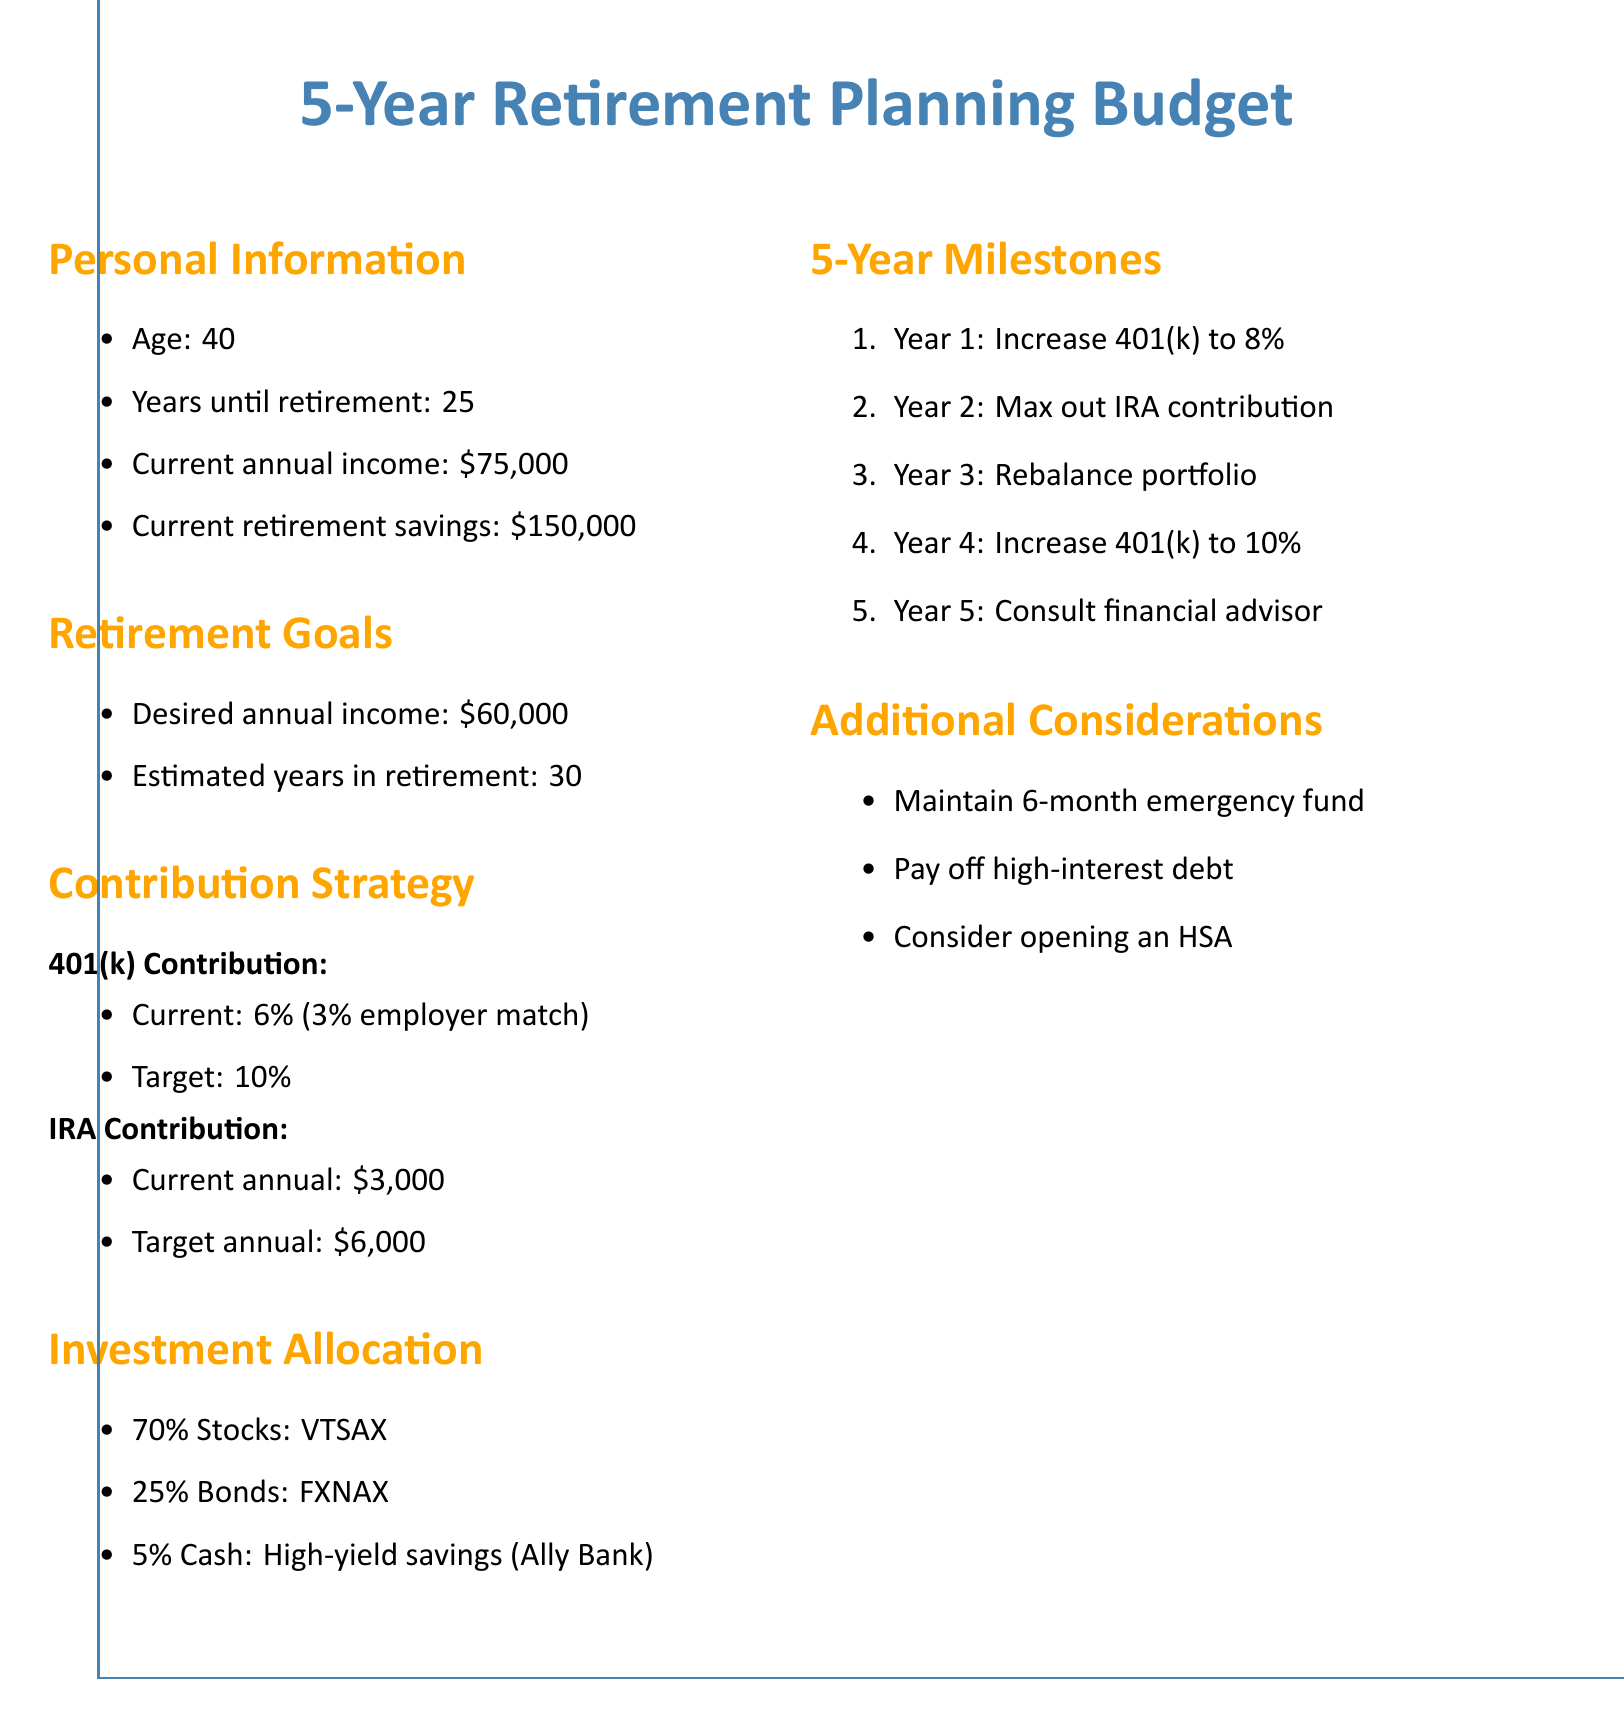What is the current annual income? The current annual income is listed in the personal information section of the document.
Answer: $75,000 What is the target annual IRA contribution? This information is found in the contribution strategy section of the document.
Answer: $6,000 What percentage of stocks is allocated in the investment strategy? This is a part of the investment allocation in the document.
Answer: 70% What is the required increase in the 401(k) contribution in Year 1? It is stated in the 5-year milestones section of the document.
Answer: 8% How many years until retirement? This information is provided in the personal information section of the document.
Answer: 25 What is the desired annual income in retirement? This can be found in the retirement goals section of the document.
Answer: $60,000 What percentage of bonds is allocated in the investment strategy? This detail can be found in the investment allocation section of the document.
Answer: 25% What is one of the additional considerations listed? This is included in the additional considerations section of the document.
Answer: Maintain 6-month emergency fund What is the estimated number of years in retirement? This information is available in the retirement goals section of the document.
Answer: 30 What is the highest contribution percentage targeted for the 401(k)? This detail is included in the contribution strategy section of the document.
Answer: 10% 